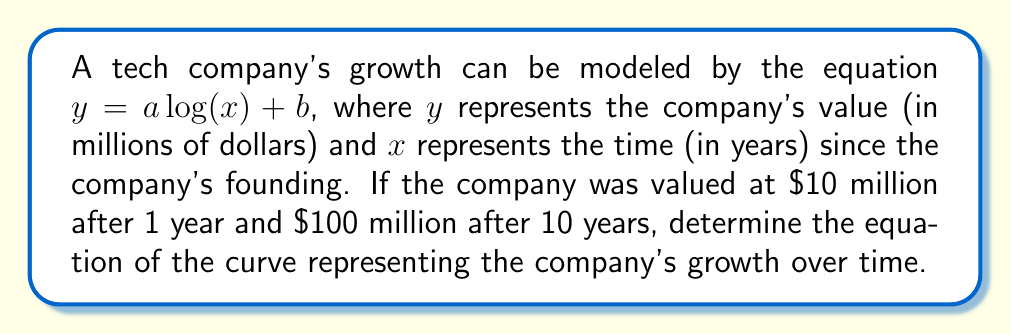What is the answer to this math problem? 1) We know that the equation has the form $y = a \log(x) + b$. We need to find the values of $a$ and $b$.

2) We have two points: $(1, 10)$ and $(10, 100)$. Let's substitute these into the equation:

   For $(1, 10)$: $10 = a \log(1) + b$
   For $(10, 100)$: $100 = a \log(10) + b$

3) Since $\log(1) = 0$, the first equation simplifies to:
   $10 = b$

4) Substituting this into the second equation:
   $100 = a \log(10) + 10$

5) Simplify:
   $90 = a \log(10)$

6) Solve for $a$:
   $a = \frac{90}{\log(10)} \approx 39.1$

7) Therefore, the equation is:
   $y = 39.1 \log(x) + 10$

8) To make it exact, we can express $a$ as a fraction:
   $a = \frac{90}{\log(10)} = \frac{90}{\ln(10)/\ln(e)} = \frac{90\ln(e)}{\ln(10)}$

9) The final equation is:
   $y = \frac{90\ln(e)}{\ln(10)} \log(x) + 10$
Answer: $y = \frac{90\ln(e)}{\ln(10)} \log(x) + 10$ 